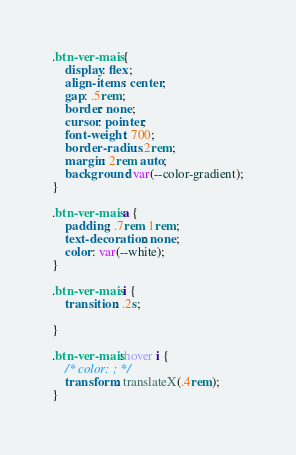Convert code to text. <code><loc_0><loc_0><loc_500><loc_500><_CSS_>

.btn-ver-mais {
    display: flex;
    align-items: center;
    gap: .5rem;
    border: none;
    cursor: pointer;
    font-weight: 700;
    border-radius: .2rem;
    margin: 2rem auto;
    background: var(--color-gradient);
}

.btn-ver-mais a {
    padding: .7rem 1rem;
    text-decoration: none;
    color: var(--white);    
}

.btn-ver-mais i {
    transition: .2s;

}

.btn-ver-mais:hover i {
    /* color: ; */
    transform: translateX(.4rem);
}</code> 